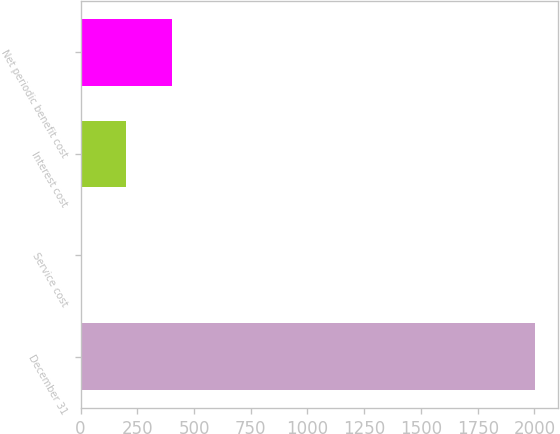Convert chart. <chart><loc_0><loc_0><loc_500><loc_500><bar_chart><fcel>December 31<fcel>Service cost<fcel>Interest cost<fcel>Net periodic benefit cost<nl><fcel>2003<fcel>1.3<fcel>201.47<fcel>401.64<nl></chart> 